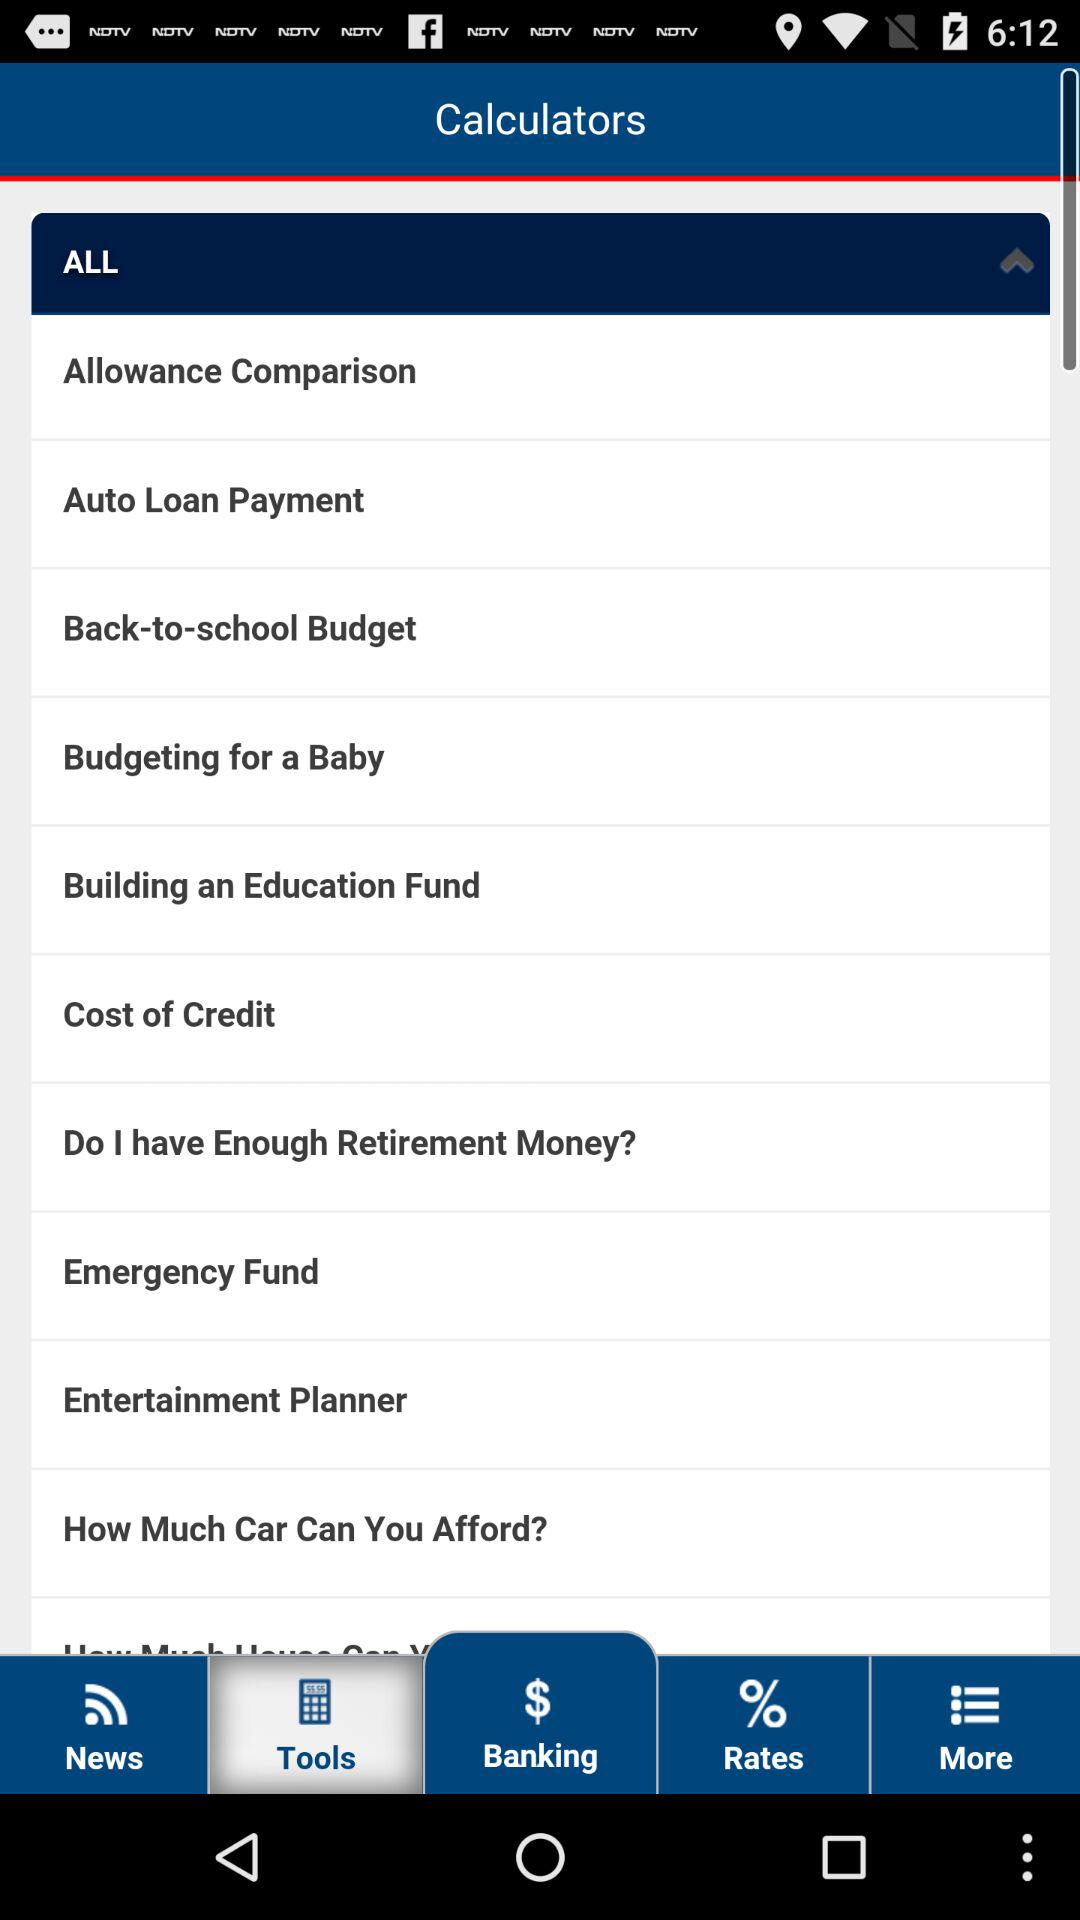Which tab is selected? The selected tab is "Tools". 